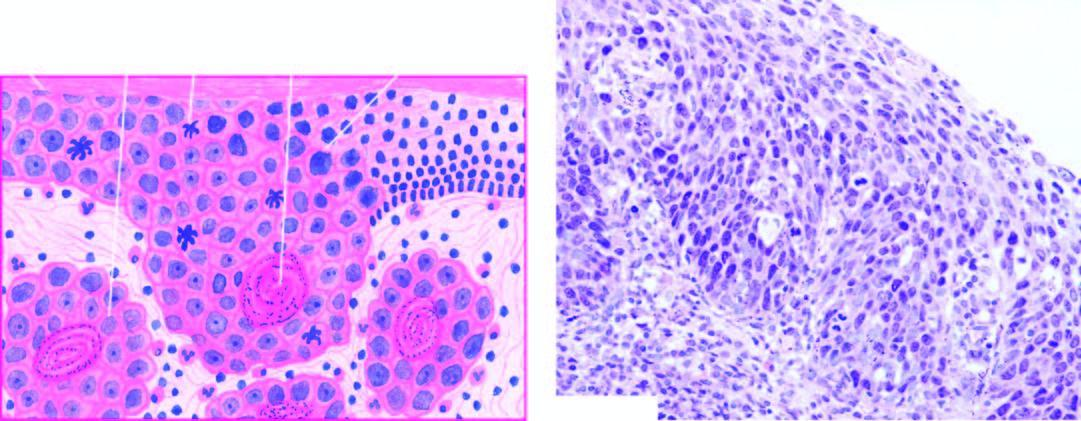what show superficial invasive islands of malignant cells in the subepithelial soft tissues?
Answer the question using a single word or phrase. A few areas 